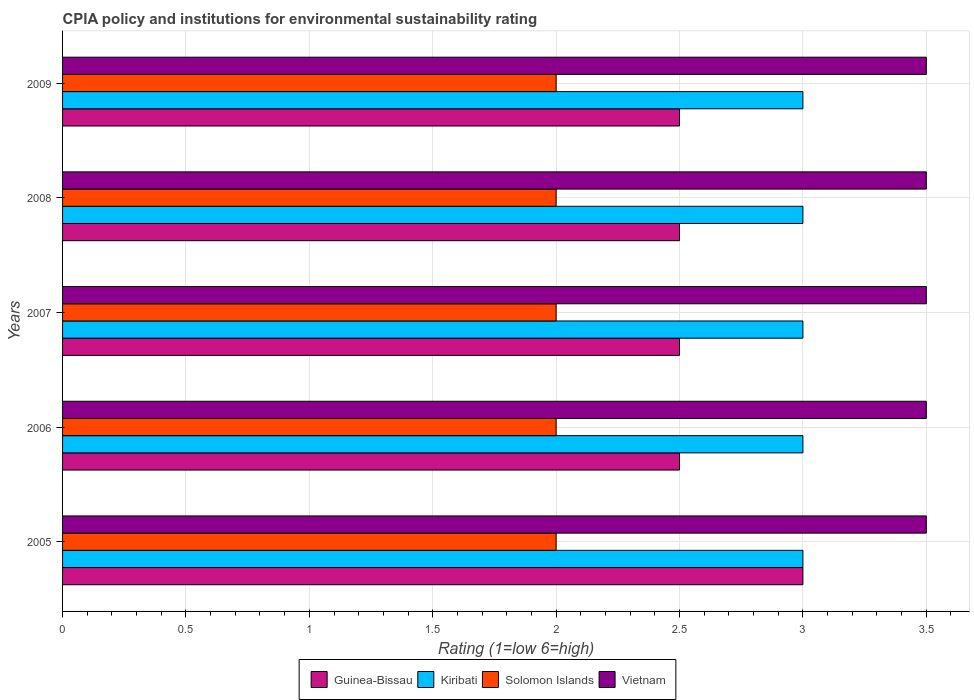How many groups of bars are there?
Make the answer very short. 5. Are the number of bars per tick equal to the number of legend labels?
Your response must be concise. Yes. How many bars are there on the 4th tick from the bottom?
Your response must be concise. 4. In how many cases, is the number of bars for a given year not equal to the number of legend labels?
Offer a very short reply. 0. Across all years, what is the minimum CPIA rating in Kiribati?
Your response must be concise. 3. What is the total CPIA rating in Vietnam in the graph?
Keep it short and to the point. 17.5. What is the difference between the CPIA rating in Kiribati in 2007 and that in 2009?
Provide a short and direct response. 0. What is the difference between the CPIA rating in Solomon Islands in 2006 and the CPIA rating in Guinea-Bissau in 2008?
Offer a very short reply. -0.5. In how many years, is the CPIA rating in Solomon Islands greater than 3.3 ?
Provide a succinct answer. 0. Is the CPIA rating in Guinea-Bissau in 2005 less than that in 2008?
Your answer should be compact. No. Is the difference between the CPIA rating in Vietnam in 2007 and 2009 greater than the difference between the CPIA rating in Solomon Islands in 2007 and 2009?
Ensure brevity in your answer.  No. What is the difference between the highest and the second highest CPIA rating in Guinea-Bissau?
Offer a very short reply. 0.5. What is the difference between the highest and the lowest CPIA rating in Solomon Islands?
Offer a terse response. 0. In how many years, is the CPIA rating in Solomon Islands greater than the average CPIA rating in Solomon Islands taken over all years?
Your answer should be compact. 0. What does the 2nd bar from the top in 2009 represents?
Your answer should be compact. Solomon Islands. What does the 3rd bar from the bottom in 2009 represents?
Your answer should be very brief. Solomon Islands. How many bars are there?
Offer a very short reply. 20. What is the difference between two consecutive major ticks on the X-axis?
Keep it short and to the point. 0.5. Where does the legend appear in the graph?
Ensure brevity in your answer.  Bottom center. How many legend labels are there?
Keep it short and to the point. 4. How are the legend labels stacked?
Keep it short and to the point. Horizontal. What is the title of the graph?
Give a very brief answer. CPIA policy and institutions for environmental sustainability rating. Does "Mauritius" appear as one of the legend labels in the graph?
Your answer should be compact. No. What is the label or title of the Y-axis?
Keep it short and to the point. Years. What is the Rating (1=low 6=high) in Kiribati in 2005?
Your response must be concise. 3. What is the Rating (1=low 6=high) of Solomon Islands in 2005?
Your answer should be compact. 2. What is the Rating (1=low 6=high) of Vietnam in 2005?
Your response must be concise. 3.5. What is the Rating (1=low 6=high) in Guinea-Bissau in 2006?
Keep it short and to the point. 2.5. What is the Rating (1=low 6=high) of Kiribati in 2006?
Make the answer very short. 3. What is the Rating (1=low 6=high) of Guinea-Bissau in 2007?
Give a very brief answer. 2.5. What is the Rating (1=low 6=high) of Solomon Islands in 2007?
Make the answer very short. 2. What is the Rating (1=low 6=high) in Guinea-Bissau in 2008?
Keep it short and to the point. 2.5. What is the Rating (1=low 6=high) of Solomon Islands in 2009?
Provide a succinct answer. 2. Across all years, what is the maximum Rating (1=low 6=high) in Guinea-Bissau?
Provide a short and direct response. 3. Across all years, what is the maximum Rating (1=low 6=high) in Kiribati?
Offer a terse response. 3. Across all years, what is the minimum Rating (1=low 6=high) of Guinea-Bissau?
Offer a terse response. 2.5. Across all years, what is the minimum Rating (1=low 6=high) of Kiribati?
Your response must be concise. 3. Across all years, what is the minimum Rating (1=low 6=high) in Solomon Islands?
Your answer should be compact. 2. What is the total Rating (1=low 6=high) in Guinea-Bissau in the graph?
Make the answer very short. 13. What is the total Rating (1=low 6=high) in Kiribati in the graph?
Give a very brief answer. 15. What is the difference between the Rating (1=low 6=high) of Guinea-Bissau in 2005 and that in 2006?
Keep it short and to the point. 0.5. What is the difference between the Rating (1=low 6=high) in Kiribati in 2005 and that in 2006?
Your response must be concise. 0. What is the difference between the Rating (1=low 6=high) of Vietnam in 2005 and that in 2006?
Provide a short and direct response. 0. What is the difference between the Rating (1=low 6=high) in Vietnam in 2005 and that in 2007?
Make the answer very short. 0. What is the difference between the Rating (1=low 6=high) in Guinea-Bissau in 2005 and that in 2008?
Your answer should be very brief. 0.5. What is the difference between the Rating (1=low 6=high) of Solomon Islands in 2005 and that in 2008?
Keep it short and to the point. 0. What is the difference between the Rating (1=low 6=high) in Guinea-Bissau in 2005 and that in 2009?
Your answer should be very brief. 0.5. What is the difference between the Rating (1=low 6=high) of Kiribati in 2005 and that in 2009?
Your answer should be compact. 0. What is the difference between the Rating (1=low 6=high) of Vietnam in 2005 and that in 2009?
Your answer should be compact. 0. What is the difference between the Rating (1=low 6=high) in Guinea-Bissau in 2006 and that in 2007?
Offer a terse response. 0. What is the difference between the Rating (1=low 6=high) of Kiribati in 2006 and that in 2007?
Your answer should be very brief. 0. What is the difference between the Rating (1=low 6=high) of Kiribati in 2006 and that in 2008?
Provide a succinct answer. 0. What is the difference between the Rating (1=low 6=high) in Solomon Islands in 2006 and that in 2008?
Keep it short and to the point. 0. What is the difference between the Rating (1=low 6=high) in Vietnam in 2006 and that in 2008?
Make the answer very short. 0. What is the difference between the Rating (1=low 6=high) in Guinea-Bissau in 2006 and that in 2009?
Provide a short and direct response. 0. What is the difference between the Rating (1=low 6=high) of Kiribati in 2006 and that in 2009?
Make the answer very short. 0. What is the difference between the Rating (1=low 6=high) of Vietnam in 2006 and that in 2009?
Provide a short and direct response. 0. What is the difference between the Rating (1=low 6=high) of Kiribati in 2007 and that in 2008?
Keep it short and to the point. 0. What is the difference between the Rating (1=low 6=high) in Solomon Islands in 2007 and that in 2008?
Your answer should be compact. 0. What is the difference between the Rating (1=low 6=high) in Guinea-Bissau in 2007 and that in 2009?
Your answer should be very brief. 0. What is the difference between the Rating (1=low 6=high) of Kiribati in 2007 and that in 2009?
Keep it short and to the point. 0. What is the difference between the Rating (1=low 6=high) of Solomon Islands in 2007 and that in 2009?
Offer a terse response. 0. What is the difference between the Rating (1=low 6=high) of Vietnam in 2007 and that in 2009?
Provide a short and direct response. 0. What is the difference between the Rating (1=low 6=high) of Guinea-Bissau in 2008 and that in 2009?
Your response must be concise. 0. What is the difference between the Rating (1=low 6=high) in Solomon Islands in 2008 and that in 2009?
Keep it short and to the point. 0. What is the difference between the Rating (1=low 6=high) in Vietnam in 2008 and that in 2009?
Keep it short and to the point. 0. What is the difference between the Rating (1=low 6=high) of Kiribati in 2005 and the Rating (1=low 6=high) of Vietnam in 2006?
Offer a very short reply. -0.5. What is the difference between the Rating (1=low 6=high) of Solomon Islands in 2005 and the Rating (1=low 6=high) of Vietnam in 2006?
Your answer should be very brief. -1.5. What is the difference between the Rating (1=low 6=high) in Guinea-Bissau in 2005 and the Rating (1=low 6=high) in Vietnam in 2007?
Give a very brief answer. -0.5. What is the difference between the Rating (1=low 6=high) in Kiribati in 2005 and the Rating (1=low 6=high) in Solomon Islands in 2007?
Provide a succinct answer. 1. What is the difference between the Rating (1=low 6=high) of Kiribati in 2005 and the Rating (1=low 6=high) of Vietnam in 2007?
Offer a terse response. -0.5. What is the difference between the Rating (1=low 6=high) of Solomon Islands in 2005 and the Rating (1=low 6=high) of Vietnam in 2007?
Offer a very short reply. -1.5. What is the difference between the Rating (1=low 6=high) in Kiribati in 2005 and the Rating (1=low 6=high) in Solomon Islands in 2008?
Your answer should be very brief. 1. What is the difference between the Rating (1=low 6=high) of Kiribati in 2005 and the Rating (1=low 6=high) of Vietnam in 2008?
Provide a short and direct response. -0.5. What is the difference between the Rating (1=low 6=high) in Guinea-Bissau in 2005 and the Rating (1=low 6=high) in Kiribati in 2009?
Provide a succinct answer. 0. What is the difference between the Rating (1=low 6=high) of Guinea-Bissau in 2005 and the Rating (1=low 6=high) of Vietnam in 2009?
Keep it short and to the point. -0.5. What is the difference between the Rating (1=low 6=high) of Kiribati in 2005 and the Rating (1=low 6=high) of Solomon Islands in 2009?
Ensure brevity in your answer.  1. What is the difference between the Rating (1=low 6=high) of Solomon Islands in 2006 and the Rating (1=low 6=high) of Vietnam in 2007?
Make the answer very short. -1.5. What is the difference between the Rating (1=low 6=high) of Guinea-Bissau in 2006 and the Rating (1=low 6=high) of Vietnam in 2008?
Ensure brevity in your answer.  -1. What is the difference between the Rating (1=low 6=high) of Kiribati in 2006 and the Rating (1=low 6=high) of Solomon Islands in 2008?
Make the answer very short. 1. What is the difference between the Rating (1=low 6=high) in Kiribati in 2006 and the Rating (1=low 6=high) in Vietnam in 2008?
Offer a very short reply. -0.5. What is the difference between the Rating (1=low 6=high) of Solomon Islands in 2006 and the Rating (1=low 6=high) of Vietnam in 2008?
Give a very brief answer. -1.5. What is the difference between the Rating (1=low 6=high) in Guinea-Bissau in 2006 and the Rating (1=low 6=high) in Solomon Islands in 2009?
Give a very brief answer. 0.5. What is the difference between the Rating (1=low 6=high) of Kiribati in 2006 and the Rating (1=low 6=high) of Solomon Islands in 2009?
Your answer should be compact. 1. What is the difference between the Rating (1=low 6=high) in Kiribati in 2006 and the Rating (1=low 6=high) in Vietnam in 2009?
Offer a terse response. -0.5. What is the difference between the Rating (1=low 6=high) in Guinea-Bissau in 2007 and the Rating (1=low 6=high) in Kiribati in 2008?
Keep it short and to the point. -0.5. What is the difference between the Rating (1=low 6=high) in Guinea-Bissau in 2007 and the Rating (1=low 6=high) in Solomon Islands in 2009?
Ensure brevity in your answer.  0.5. What is the difference between the Rating (1=low 6=high) in Guinea-Bissau in 2007 and the Rating (1=low 6=high) in Vietnam in 2009?
Offer a terse response. -1. What is the difference between the Rating (1=low 6=high) of Kiribati in 2007 and the Rating (1=low 6=high) of Vietnam in 2009?
Your answer should be very brief. -0.5. What is the difference between the Rating (1=low 6=high) of Guinea-Bissau in 2008 and the Rating (1=low 6=high) of Kiribati in 2009?
Your answer should be compact. -0.5. What is the difference between the Rating (1=low 6=high) of Guinea-Bissau in 2008 and the Rating (1=low 6=high) of Vietnam in 2009?
Offer a very short reply. -1. What is the difference between the Rating (1=low 6=high) in Kiribati in 2008 and the Rating (1=low 6=high) in Solomon Islands in 2009?
Ensure brevity in your answer.  1. What is the difference between the Rating (1=low 6=high) of Kiribati in 2008 and the Rating (1=low 6=high) of Vietnam in 2009?
Your answer should be compact. -0.5. What is the average Rating (1=low 6=high) of Guinea-Bissau per year?
Give a very brief answer. 2.6. What is the average Rating (1=low 6=high) of Kiribati per year?
Offer a terse response. 3. What is the average Rating (1=low 6=high) of Vietnam per year?
Offer a very short reply. 3.5. In the year 2005, what is the difference between the Rating (1=low 6=high) of Guinea-Bissau and Rating (1=low 6=high) of Kiribati?
Your response must be concise. 0. In the year 2005, what is the difference between the Rating (1=low 6=high) of Guinea-Bissau and Rating (1=low 6=high) of Solomon Islands?
Provide a short and direct response. 1. In the year 2005, what is the difference between the Rating (1=low 6=high) in Kiribati and Rating (1=low 6=high) in Solomon Islands?
Keep it short and to the point. 1. In the year 2005, what is the difference between the Rating (1=low 6=high) of Kiribati and Rating (1=low 6=high) of Vietnam?
Keep it short and to the point. -0.5. In the year 2006, what is the difference between the Rating (1=low 6=high) of Guinea-Bissau and Rating (1=low 6=high) of Kiribati?
Your answer should be compact. -0.5. In the year 2006, what is the difference between the Rating (1=low 6=high) of Kiribati and Rating (1=low 6=high) of Vietnam?
Keep it short and to the point. -0.5. In the year 2006, what is the difference between the Rating (1=low 6=high) of Solomon Islands and Rating (1=low 6=high) of Vietnam?
Ensure brevity in your answer.  -1.5. In the year 2007, what is the difference between the Rating (1=low 6=high) of Guinea-Bissau and Rating (1=low 6=high) of Kiribati?
Provide a short and direct response. -0.5. In the year 2007, what is the difference between the Rating (1=low 6=high) in Guinea-Bissau and Rating (1=low 6=high) in Solomon Islands?
Give a very brief answer. 0.5. In the year 2007, what is the difference between the Rating (1=low 6=high) in Guinea-Bissau and Rating (1=low 6=high) in Vietnam?
Make the answer very short. -1. In the year 2007, what is the difference between the Rating (1=low 6=high) in Kiribati and Rating (1=low 6=high) in Solomon Islands?
Keep it short and to the point. 1. In the year 2007, what is the difference between the Rating (1=low 6=high) of Kiribati and Rating (1=low 6=high) of Vietnam?
Offer a terse response. -0.5. In the year 2007, what is the difference between the Rating (1=low 6=high) in Solomon Islands and Rating (1=low 6=high) in Vietnam?
Provide a succinct answer. -1.5. In the year 2008, what is the difference between the Rating (1=low 6=high) of Guinea-Bissau and Rating (1=low 6=high) of Kiribati?
Provide a succinct answer. -0.5. In the year 2008, what is the difference between the Rating (1=low 6=high) of Guinea-Bissau and Rating (1=low 6=high) of Solomon Islands?
Provide a succinct answer. 0.5. In the year 2008, what is the difference between the Rating (1=low 6=high) of Guinea-Bissau and Rating (1=low 6=high) of Vietnam?
Provide a succinct answer. -1. In the year 2008, what is the difference between the Rating (1=low 6=high) in Kiribati and Rating (1=low 6=high) in Solomon Islands?
Your answer should be very brief. 1. In the year 2008, what is the difference between the Rating (1=low 6=high) of Kiribati and Rating (1=low 6=high) of Vietnam?
Your response must be concise. -0.5. In the year 2009, what is the difference between the Rating (1=low 6=high) in Guinea-Bissau and Rating (1=low 6=high) in Kiribati?
Offer a terse response. -0.5. In the year 2009, what is the difference between the Rating (1=low 6=high) in Guinea-Bissau and Rating (1=low 6=high) in Vietnam?
Your response must be concise. -1. In the year 2009, what is the difference between the Rating (1=low 6=high) in Kiribati and Rating (1=low 6=high) in Vietnam?
Your response must be concise. -0.5. What is the ratio of the Rating (1=low 6=high) of Guinea-Bissau in 2005 to that in 2006?
Your response must be concise. 1.2. What is the ratio of the Rating (1=low 6=high) of Solomon Islands in 2005 to that in 2006?
Provide a succinct answer. 1. What is the ratio of the Rating (1=low 6=high) of Vietnam in 2005 to that in 2006?
Provide a succinct answer. 1. What is the ratio of the Rating (1=low 6=high) in Solomon Islands in 2005 to that in 2007?
Offer a very short reply. 1. What is the ratio of the Rating (1=low 6=high) of Vietnam in 2005 to that in 2007?
Provide a short and direct response. 1. What is the ratio of the Rating (1=low 6=high) in Kiribati in 2005 to that in 2008?
Provide a short and direct response. 1. What is the ratio of the Rating (1=low 6=high) in Kiribati in 2005 to that in 2009?
Provide a short and direct response. 1. What is the ratio of the Rating (1=low 6=high) of Guinea-Bissau in 2006 to that in 2007?
Provide a short and direct response. 1. What is the ratio of the Rating (1=low 6=high) in Kiribati in 2006 to that in 2007?
Give a very brief answer. 1. What is the ratio of the Rating (1=low 6=high) of Solomon Islands in 2006 to that in 2007?
Your response must be concise. 1. What is the ratio of the Rating (1=low 6=high) in Kiribati in 2006 to that in 2008?
Make the answer very short. 1. What is the ratio of the Rating (1=low 6=high) of Solomon Islands in 2006 to that in 2008?
Ensure brevity in your answer.  1. What is the ratio of the Rating (1=low 6=high) of Vietnam in 2006 to that in 2008?
Your response must be concise. 1. What is the ratio of the Rating (1=low 6=high) in Guinea-Bissau in 2006 to that in 2009?
Make the answer very short. 1. What is the ratio of the Rating (1=low 6=high) of Kiribati in 2006 to that in 2009?
Offer a very short reply. 1. What is the ratio of the Rating (1=low 6=high) in Vietnam in 2006 to that in 2009?
Provide a short and direct response. 1. What is the ratio of the Rating (1=low 6=high) in Guinea-Bissau in 2007 to that in 2008?
Provide a short and direct response. 1. What is the ratio of the Rating (1=low 6=high) of Kiribati in 2007 to that in 2008?
Offer a terse response. 1. What is the ratio of the Rating (1=low 6=high) in Solomon Islands in 2007 to that in 2008?
Make the answer very short. 1. What is the ratio of the Rating (1=low 6=high) in Vietnam in 2007 to that in 2008?
Provide a succinct answer. 1. What is the ratio of the Rating (1=low 6=high) in Kiribati in 2007 to that in 2009?
Offer a terse response. 1. What is the ratio of the Rating (1=low 6=high) of Vietnam in 2007 to that in 2009?
Make the answer very short. 1. What is the ratio of the Rating (1=low 6=high) of Kiribati in 2008 to that in 2009?
Your answer should be very brief. 1. What is the ratio of the Rating (1=low 6=high) in Solomon Islands in 2008 to that in 2009?
Ensure brevity in your answer.  1. What is the ratio of the Rating (1=low 6=high) of Vietnam in 2008 to that in 2009?
Offer a terse response. 1. What is the difference between the highest and the second highest Rating (1=low 6=high) of Vietnam?
Keep it short and to the point. 0. What is the difference between the highest and the lowest Rating (1=low 6=high) in Kiribati?
Provide a short and direct response. 0. What is the difference between the highest and the lowest Rating (1=low 6=high) of Vietnam?
Keep it short and to the point. 0. 